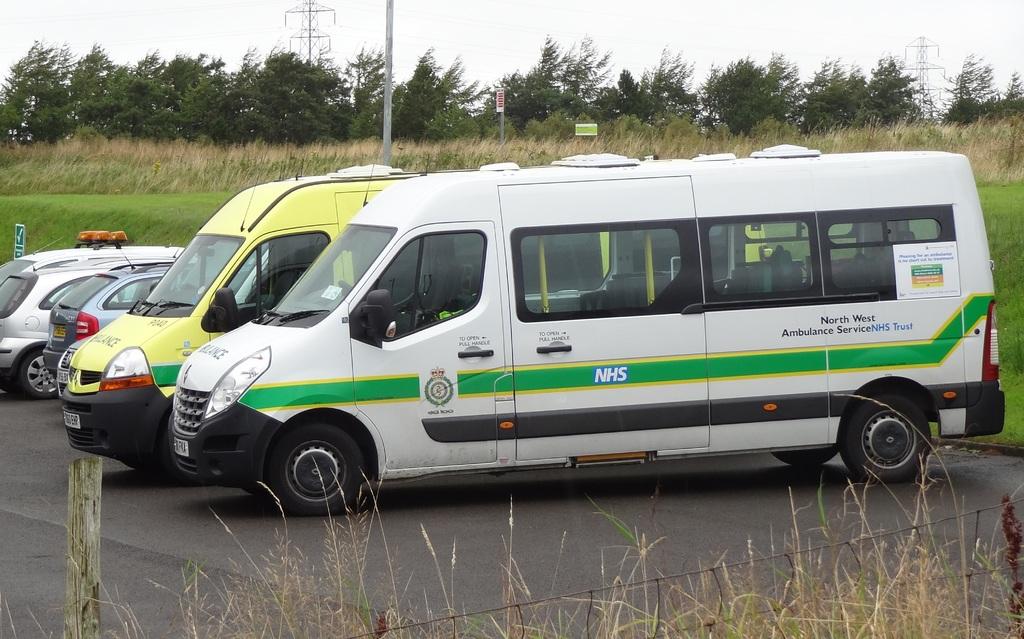What does that van say?
Your answer should be very brief. North west ambulance service. What type of vehicule is this?
Make the answer very short. Ambulance. 